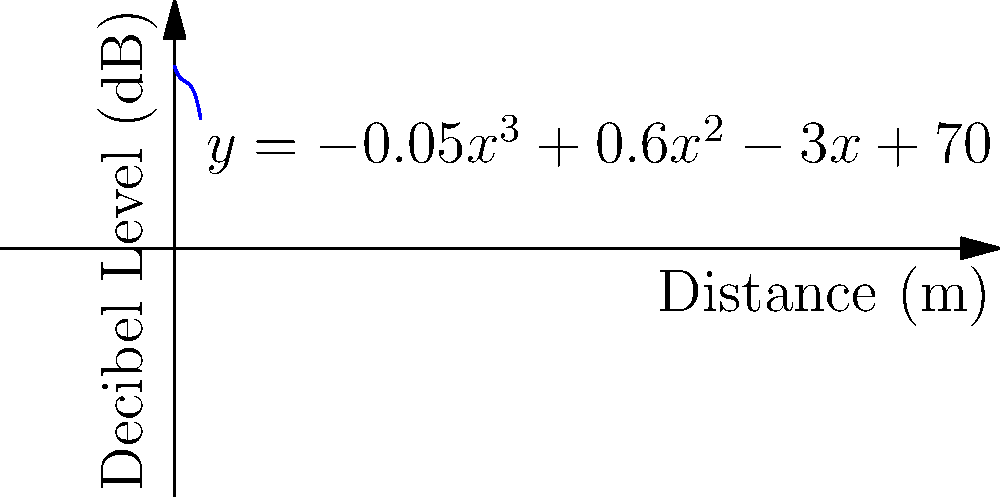Given the polynomial function $f(x) = -0.05x^3 + 0.6x^2 - 3x + 70$ representing the decibel levels at different distances from a classical music performance, where $x$ is the distance in meters and $f(x)$ is the decibel level, at what distance will the decibel level be approximately 60 dB? To find the distance where the decibel level is 60 dB, we need to solve the equation:

$-0.05x^3 + 0.6x^2 - 3x + 70 = 60$

Rearranging the equation:

$-0.05x^3 + 0.6x^2 - 3x + 10 = 0$

This is a cubic equation and can be solved using various methods. One approach is to use a graphing calculator or computer software to find the roots.

Using such a tool, we find that the equation has three roots:
1. Approximately 0.37 meters
2. Approximately 3.41 meters
3. Approximately 8.22 meters

Since we're looking for a realistic distance from the performance, the middle value of about 3.41 meters is the most appropriate answer.
Answer: 3.41 meters 